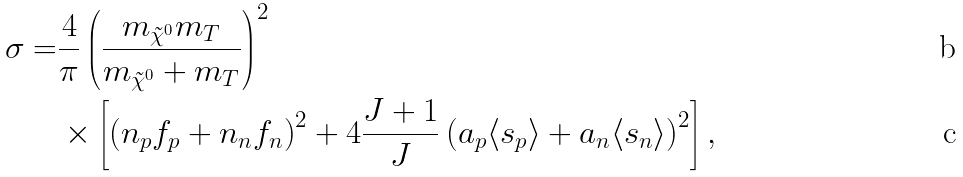Convert formula to latex. <formula><loc_0><loc_0><loc_500><loc_500>\sigma = & \frac { 4 } { \pi } \left ( \frac { m _ { \tilde { \chi } ^ { 0 } } m _ { T } } { m _ { \tilde { \chi } ^ { 0 } } + m _ { T } } \right ) ^ { 2 } \\ & \times \left [ \left ( n _ { p } f _ { p } + n _ { n } f _ { n } \right ) ^ { 2 } + 4 \frac { J + 1 } { J } \left ( a _ { p } \langle s _ { p } \rangle + a _ { n } \langle s _ { n } \rangle \right ) ^ { 2 } \right ] ,</formula> 